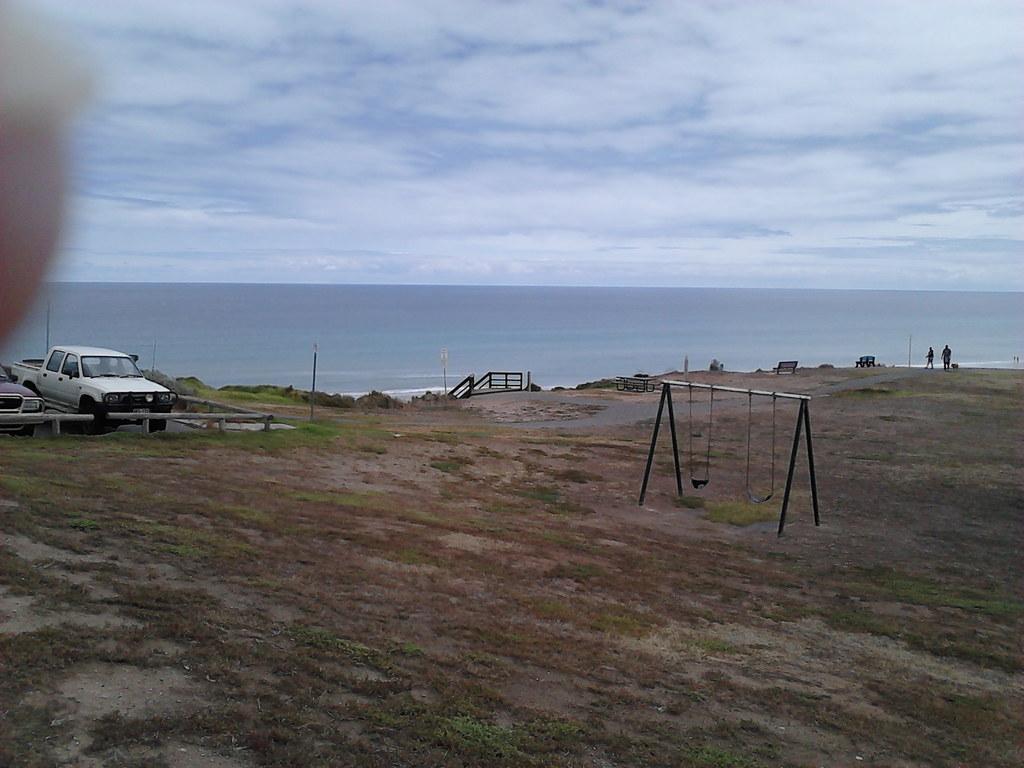Could you give a brief overview of what you see in this image? In this image, we can see swing set, benches, stairs, people, some poles, a fence, and some vehicles on the road and there is ground and water. At the top, there are clouds in the sky. 